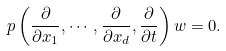Convert formula to latex. <formula><loc_0><loc_0><loc_500><loc_500>p \left ( \frac { \partial } { \partial x _ { 1 } } , \cdots , \frac { \partial } { \partial x _ { d } } , \frac { \partial } { \partial t } \right ) w = 0 .</formula> 